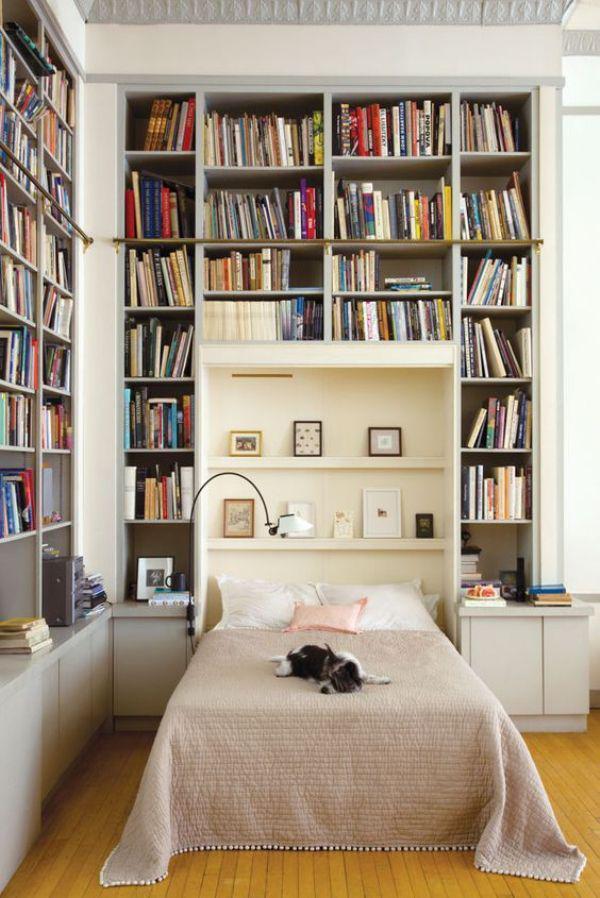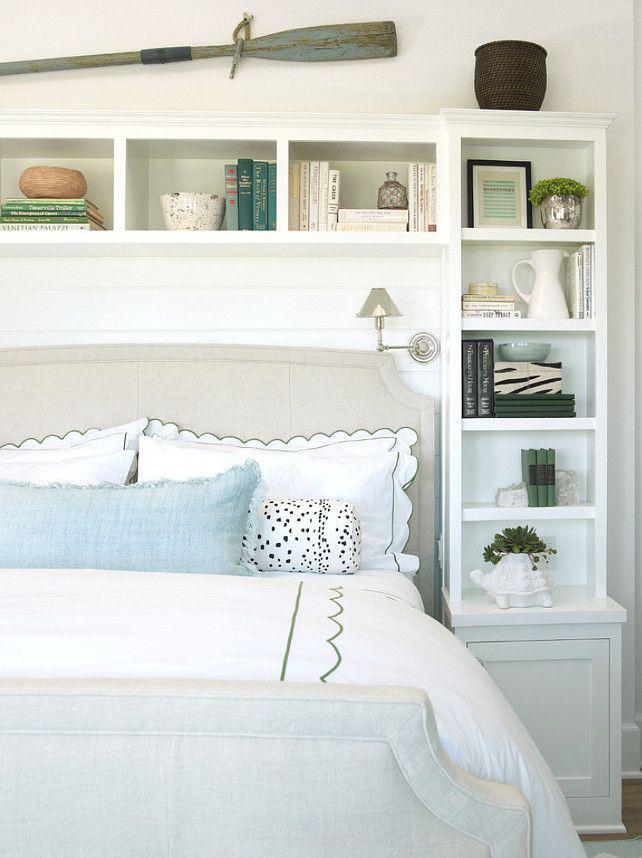The first image is the image on the left, the second image is the image on the right. Considering the images on both sides, is "A rug sits on the floor in the image on the left." valid? Answer yes or no. No. 